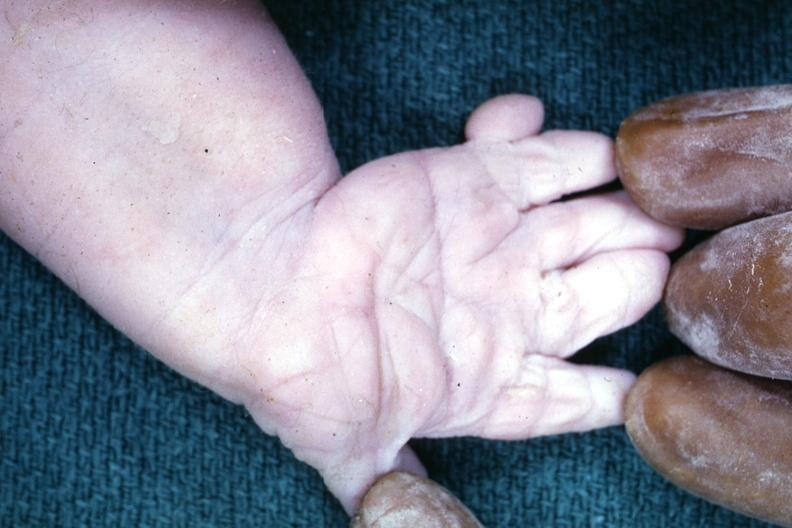re sets present?
Answer the question using a single word or phrase. No 